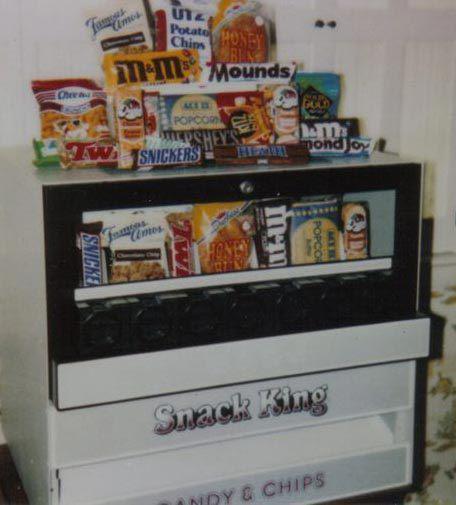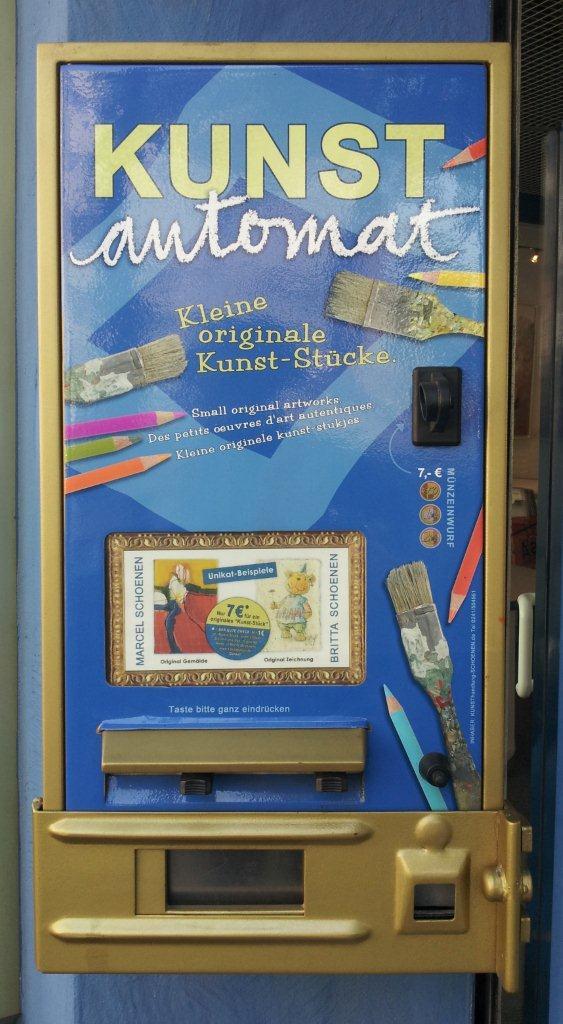The first image is the image on the left, the second image is the image on the right. Assess this claim about the two images: "Knobs can be seen beneath a single row of candies on the vending machine in one of the images.". Correct or not? Answer yes or no. No. 